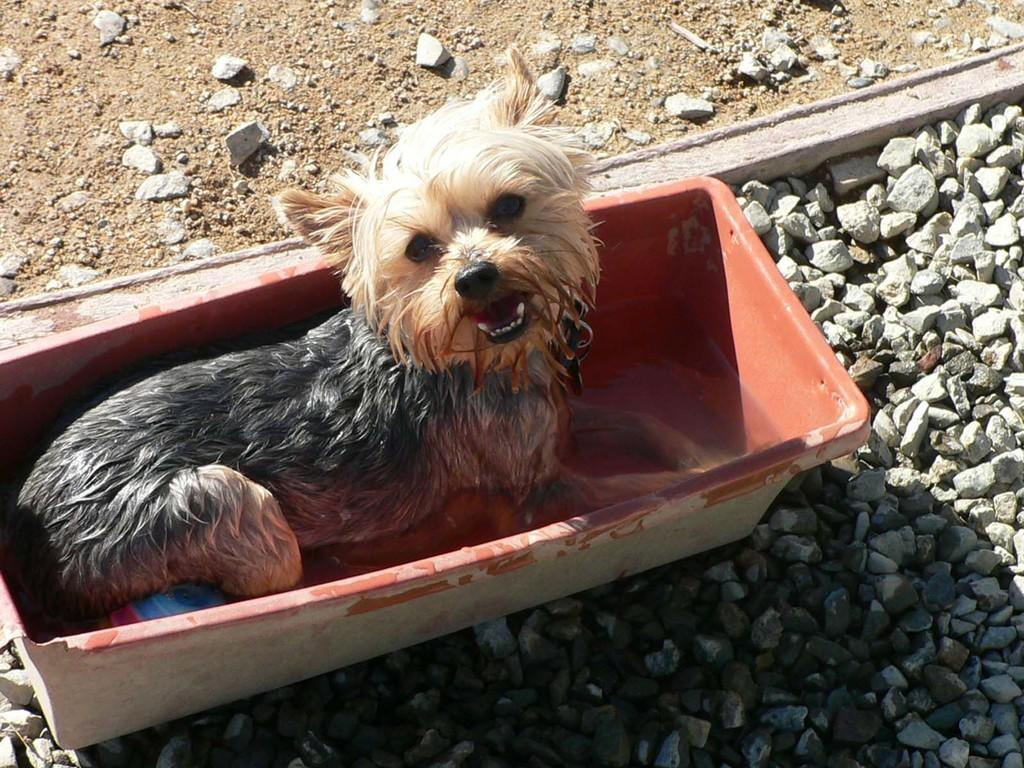What is the dog doing in the image? The dog is in the tub in the image. What can be found at the bottom of the image? There are stones at the bottom of the image. Where is the table located in the image? There is no table present in the image. What type of form is the goldfish taking in the image? There is no goldfish present in the image. 